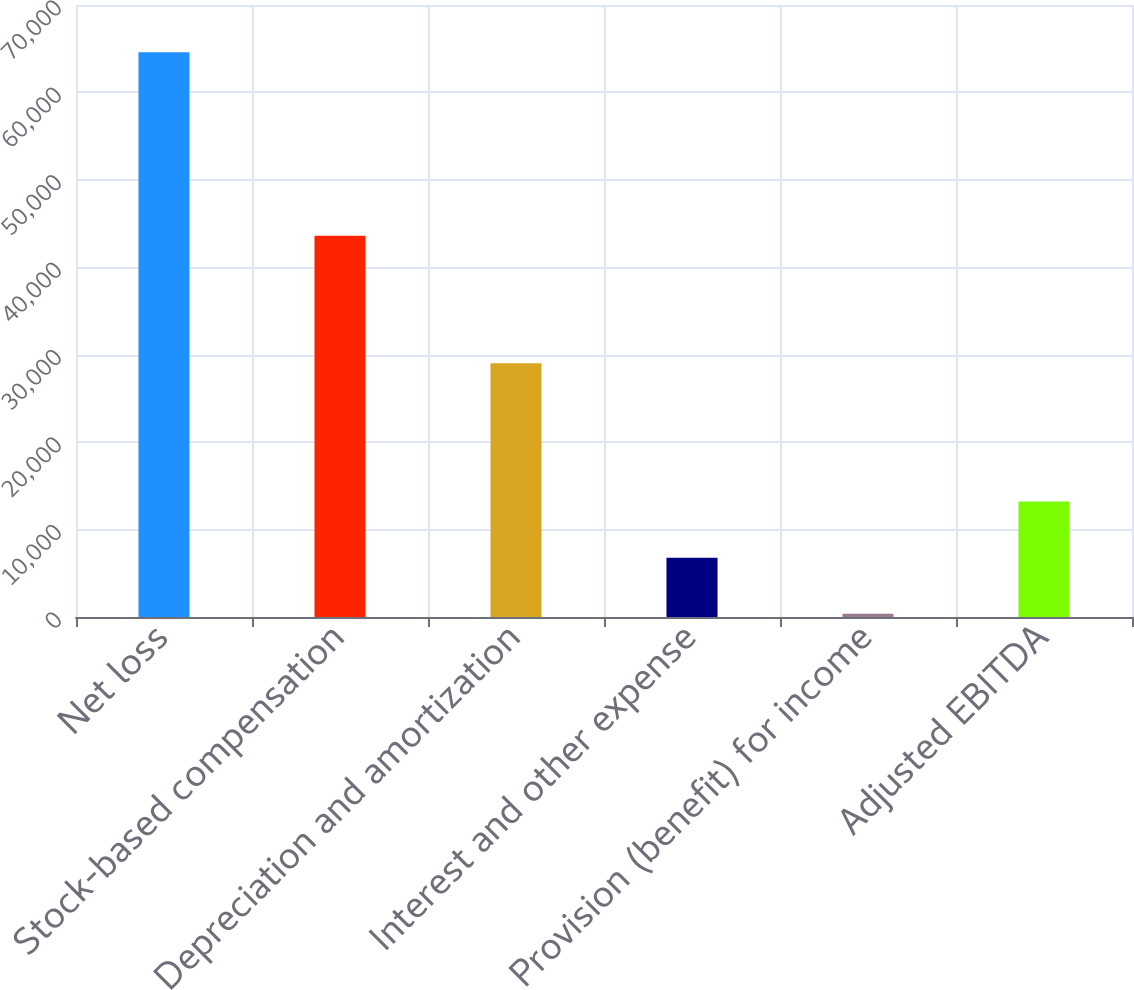<chart> <loc_0><loc_0><loc_500><loc_500><bar_chart><fcel>Net loss<fcel>Stock-based compensation<fcel>Depreciation and amortization<fcel>Interest and other expense<fcel>Provision (benefit) for income<fcel>Adjusted EBITDA<nl><fcel>64601<fcel>43602<fcel>29023<fcel>6784.1<fcel>360<fcel>13208.2<nl></chart> 